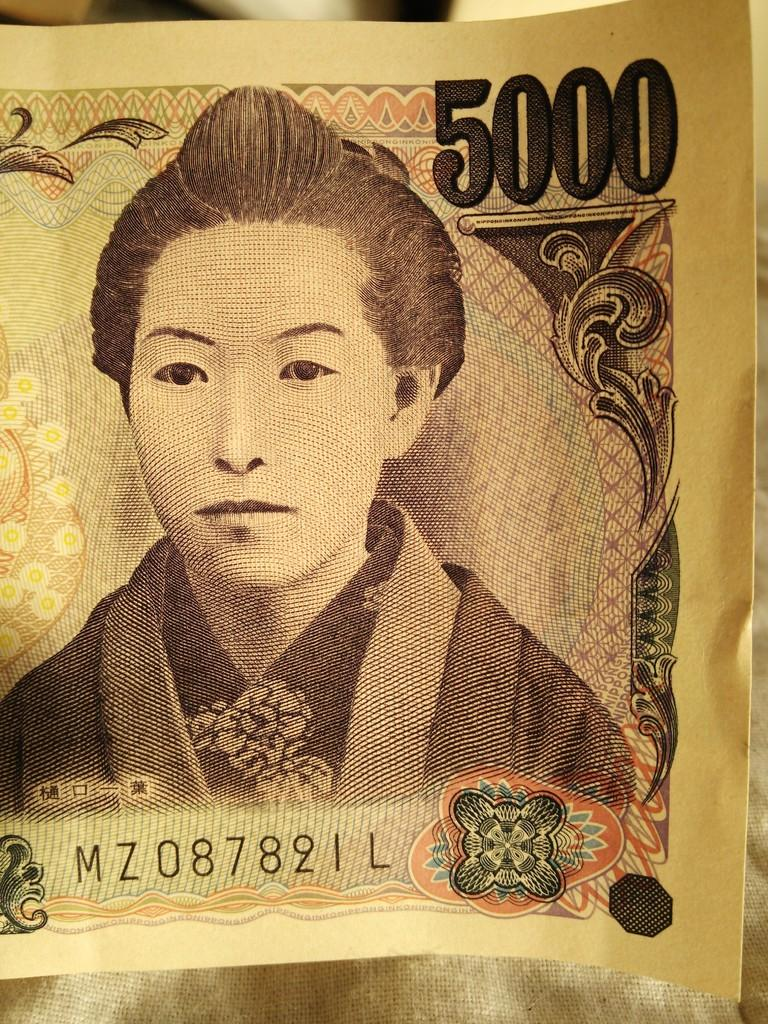Who is depicted on the currency note in the image? There is an image of a person on the currency note. What else can be seen on the currency note besides the person's image? There are numbers visible on the currency note. What type of cork can be seen holding the currency note in the image? There is no cork present in the image, and the currency note is not being held by any object. 